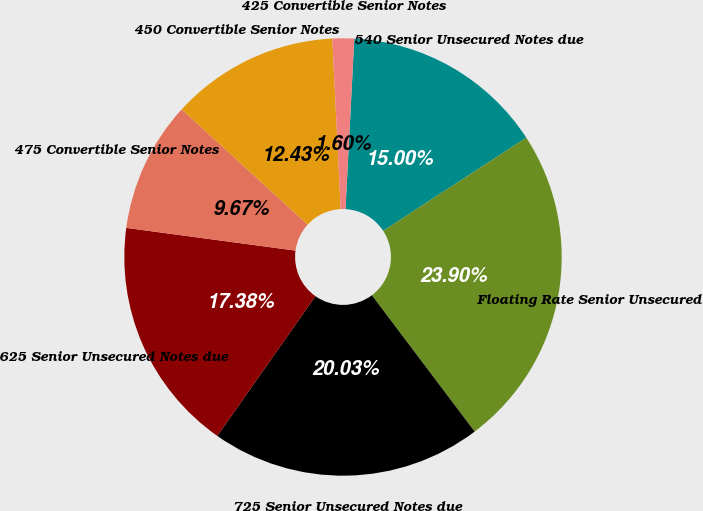Convert chart. <chart><loc_0><loc_0><loc_500><loc_500><pie_chart><fcel>540 Senior Unsecured Notes due<fcel>Floating Rate Senior Unsecured<fcel>725 Senior Unsecured Notes due<fcel>625 Senior Unsecured Notes due<fcel>475 Convertible Senior Notes<fcel>450 Convertible Senior Notes<fcel>425 Convertible Senior Notes<nl><fcel>15.0%<fcel>23.9%<fcel>20.03%<fcel>17.38%<fcel>9.67%<fcel>12.43%<fcel>1.6%<nl></chart> 